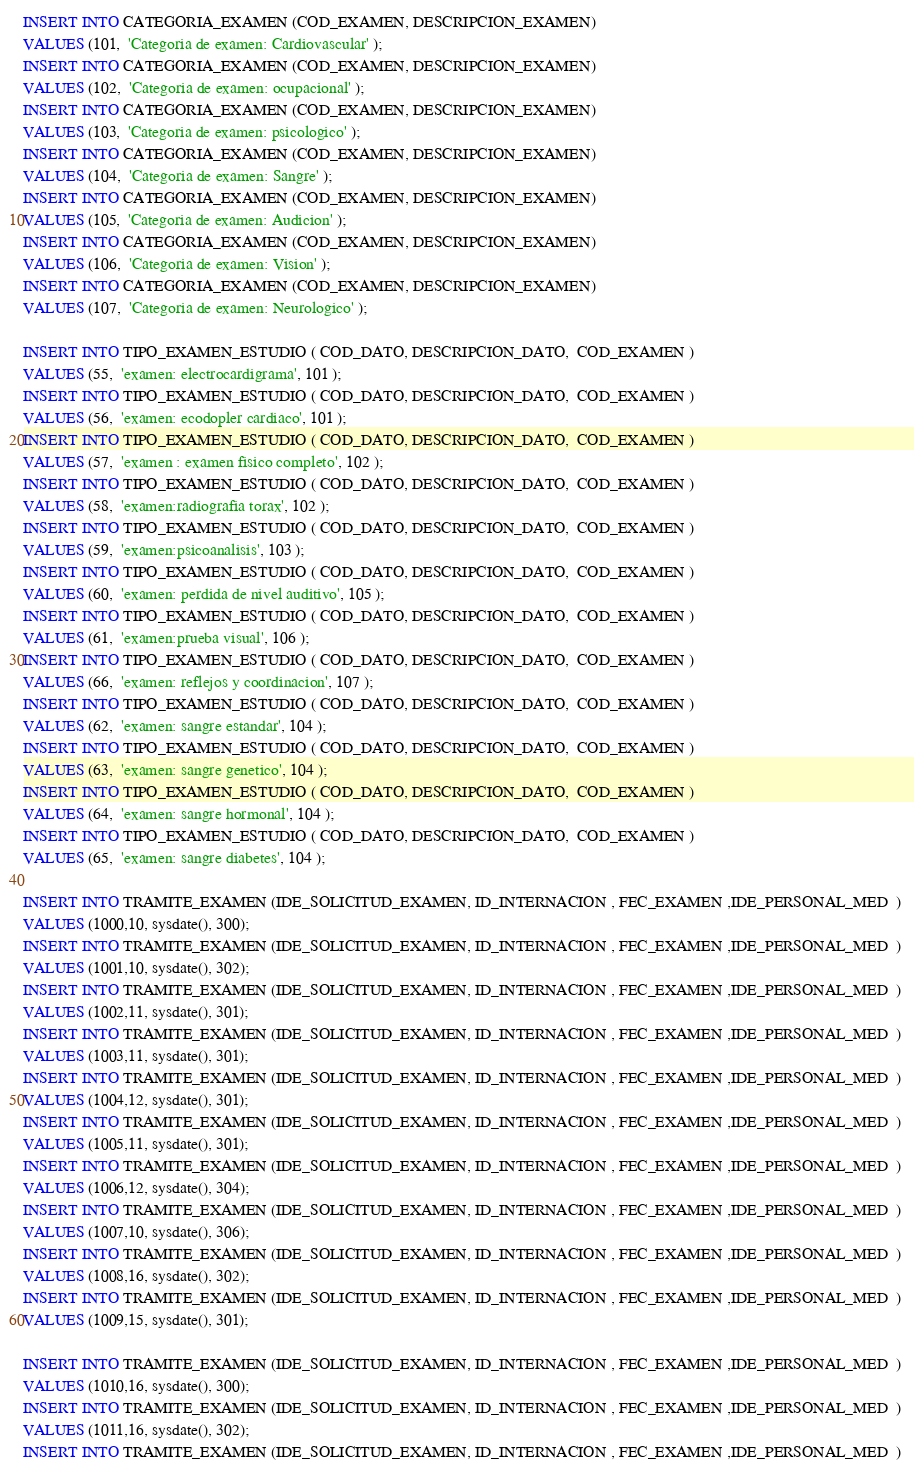<code> <loc_0><loc_0><loc_500><loc_500><_SQL_>INSERT INTO CATEGORIA_EXAMEN (COD_EXAMEN, DESCRIPCION_EXAMEN) 
VALUES (101,  'Categoria de examen: Cardiovascular' );
INSERT INTO CATEGORIA_EXAMEN (COD_EXAMEN, DESCRIPCION_EXAMEN) 
VALUES (102,  'Categoria de examen: ocupacional' );
INSERT INTO CATEGORIA_EXAMEN (COD_EXAMEN, DESCRIPCION_EXAMEN) 
VALUES (103,  'Categoria de examen: psicologico' );
INSERT INTO CATEGORIA_EXAMEN (COD_EXAMEN, DESCRIPCION_EXAMEN) 
VALUES (104,  'Categoria de examen: Sangre' );
INSERT INTO CATEGORIA_EXAMEN (COD_EXAMEN, DESCRIPCION_EXAMEN) 
VALUES (105,  'Categoria de examen: Audicion' );
INSERT INTO CATEGORIA_EXAMEN (COD_EXAMEN, DESCRIPCION_EXAMEN) 
VALUES (106,  'Categoria de examen: Vision' );
INSERT INTO CATEGORIA_EXAMEN (COD_EXAMEN, DESCRIPCION_EXAMEN) 
VALUES (107,  'Categoria de examen: Neurologico' );

INSERT INTO TIPO_EXAMEN_ESTUDIO ( COD_DATO, DESCRIPCION_DATO,  COD_EXAMEN ) 
VALUES (55,  'examen: electrocardigrama', 101 );
INSERT INTO TIPO_EXAMEN_ESTUDIO ( COD_DATO, DESCRIPCION_DATO,  COD_EXAMEN ) 
VALUES (56,  'examen: ecodopler cardiaco', 101 );
INSERT INTO TIPO_EXAMEN_ESTUDIO ( COD_DATO, DESCRIPCION_DATO,  COD_EXAMEN ) 
VALUES (57,  'examen : examen fisico completo', 102 );
INSERT INTO TIPO_EXAMEN_ESTUDIO ( COD_DATO, DESCRIPCION_DATO,  COD_EXAMEN ) 
VALUES (58,  'examen:radiografia torax', 102 );
INSERT INTO TIPO_EXAMEN_ESTUDIO ( COD_DATO, DESCRIPCION_DATO,  COD_EXAMEN ) 
VALUES (59,  'examen:psicoanalisis', 103 );
INSERT INTO TIPO_EXAMEN_ESTUDIO ( COD_DATO, DESCRIPCION_DATO,  COD_EXAMEN ) 
VALUES (60,  'examen: perdida de nivel auditivo', 105 );
INSERT INTO TIPO_EXAMEN_ESTUDIO ( COD_DATO, DESCRIPCION_DATO,  COD_EXAMEN ) 
VALUES (61,  'examen:prueba visual', 106 );
INSERT INTO TIPO_EXAMEN_ESTUDIO ( COD_DATO, DESCRIPCION_DATO,  COD_EXAMEN ) 
VALUES (66,  'examen: reflejos y coordinacion', 107 );
INSERT INTO TIPO_EXAMEN_ESTUDIO ( COD_DATO, DESCRIPCION_DATO,  COD_EXAMEN ) 
VALUES (62,  'examen: sangre estandar', 104 );
INSERT INTO TIPO_EXAMEN_ESTUDIO ( COD_DATO, DESCRIPCION_DATO,  COD_EXAMEN ) 
VALUES (63,  'examen: sangre genetico', 104 );
INSERT INTO TIPO_EXAMEN_ESTUDIO ( COD_DATO, DESCRIPCION_DATO,  COD_EXAMEN ) 
VALUES (64,  'examen: sangre hormonal', 104 );
INSERT INTO TIPO_EXAMEN_ESTUDIO ( COD_DATO, DESCRIPCION_DATO,  COD_EXAMEN ) 
VALUES (65,  'examen: sangre diabetes', 104 );

INSERT INTO TRAMITE_EXAMEN (IDE_SOLICITUD_EXAMEN, ID_INTERNACION , FEC_EXAMEN ,IDE_PERSONAL_MED  ) 
VALUES (1000,10, sysdate(), 300);
INSERT INTO TRAMITE_EXAMEN (IDE_SOLICITUD_EXAMEN, ID_INTERNACION , FEC_EXAMEN ,IDE_PERSONAL_MED  ) 
VALUES (1001,10, sysdate(), 302);
INSERT INTO TRAMITE_EXAMEN (IDE_SOLICITUD_EXAMEN, ID_INTERNACION , FEC_EXAMEN ,IDE_PERSONAL_MED  ) 
VALUES (1002,11, sysdate(), 301);
INSERT INTO TRAMITE_EXAMEN (IDE_SOLICITUD_EXAMEN, ID_INTERNACION , FEC_EXAMEN ,IDE_PERSONAL_MED  ) 
VALUES (1003,11, sysdate(), 301);
INSERT INTO TRAMITE_EXAMEN (IDE_SOLICITUD_EXAMEN, ID_INTERNACION , FEC_EXAMEN ,IDE_PERSONAL_MED  ) 
VALUES (1004,12, sysdate(), 301);
INSERT INTO TRAMITE_EXAMEN (IDE_SOLICITUD_EXAMEN, ID_INTERNACION , FEC_EXAMEN ,IDE_PERSONAL_MED  ) 
VALUES (1005,11, sysdate(), 301);
INSERT INTO TRAMITE_EXAMEN (IDE_SOLICITUD_EXAMEN, ID_INTERNACION , FEC_EXAMEN ,IDE_PERSONAL_MED  ) 
VALUES (1006,12, sysdate(), 304);
INSERT INTO TRAMITE_EXAMEN (IDE_SOLICITUD_EXAMEN, ID_INTERNACION , FEC_EXAMEN ,IDE_PERSONAL_MED  ) 
VALUES (1007,10, sysdate(), 306);
INSERT INTO TRAMITE_EXAMEN (IDE_SOLICITUD_EXAMEN, ID_INTERNACION , FEC_EXAMEN ,IDE_PERSONAL_MED  ) 
VALUES (1008,16, sysdate(), 302);
INSERT INTO TRAMITE_EXAMEN (IDE_SOLICITUD_EXAMEN, ID_INTERNACION , FEC_EXAMEN ,IDE_PERSONAL_MED  ) 
VALUES (1009,15, sysdate(), 301);

INSERT INTO TRAMITE_EXAMEN (IDE_SOLICITUD_EXAMEN, ID_INTERNACION , FEC_EXAMEN ,IDE_PERSONAL_MED  ) 
VALUES (1010,16, sysdate(), 300);
INSERT INTO TRAMITE_EXAMEN (IDE_SOLICITUD_EXAMEN, ID_INTERNACION , FEC_EXAMEN ,IDE_PERSONAL_MED  ) 
VALUES (1011,16, sysdate(), 302);
INSERT INTO TRAMITE_EXAMEN (IDE_SOLICITUD_EXAMEN, ID_INTERNACION , FEC_EXAMEN ,IDE_PERSONAL_MED  ) </code> 